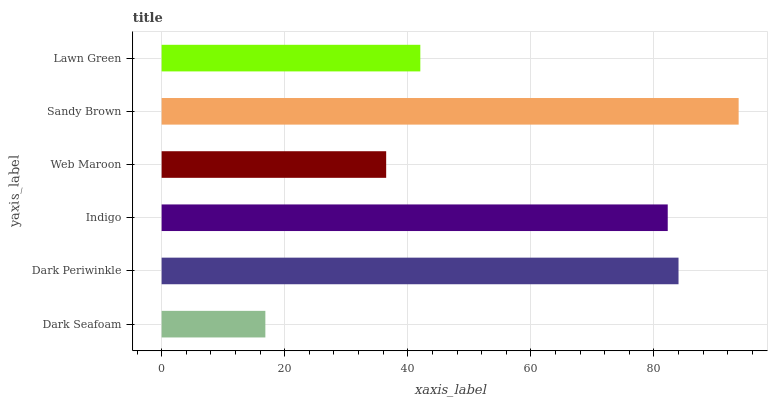Is Dark Seafoam the minimum?
Answer yes or no. Yes. Is Sandy Brown the maximum?
Answer yes or no. Yes. Is Dark Periwinkle the minimum?
Answer yes or no. No. Is Dark Periwinkle the maximum?
Answer yes or no. No. Is Dark Periwinkle greater than Dark Seafoam?
Answer yes or no. Yes. Is Dark Seafoam less than Dark Periwinkle?
Answer yes or no. Yes. Is Dark Seafoam greater than Dark Periwinkle?
Answer yes or no. No. Is Dark Periwinkle less than Dark Seafoam?
Answer yes or no. No. Is Indigo the high median?
Answer yes or no. Yes. Is Lawn Green the low median?
Answer yes or no. Yes. Is Web Maroon the high median?
Answer yes or no. No. Is Sandy Brown the low median?
Answer yes or no. No. 